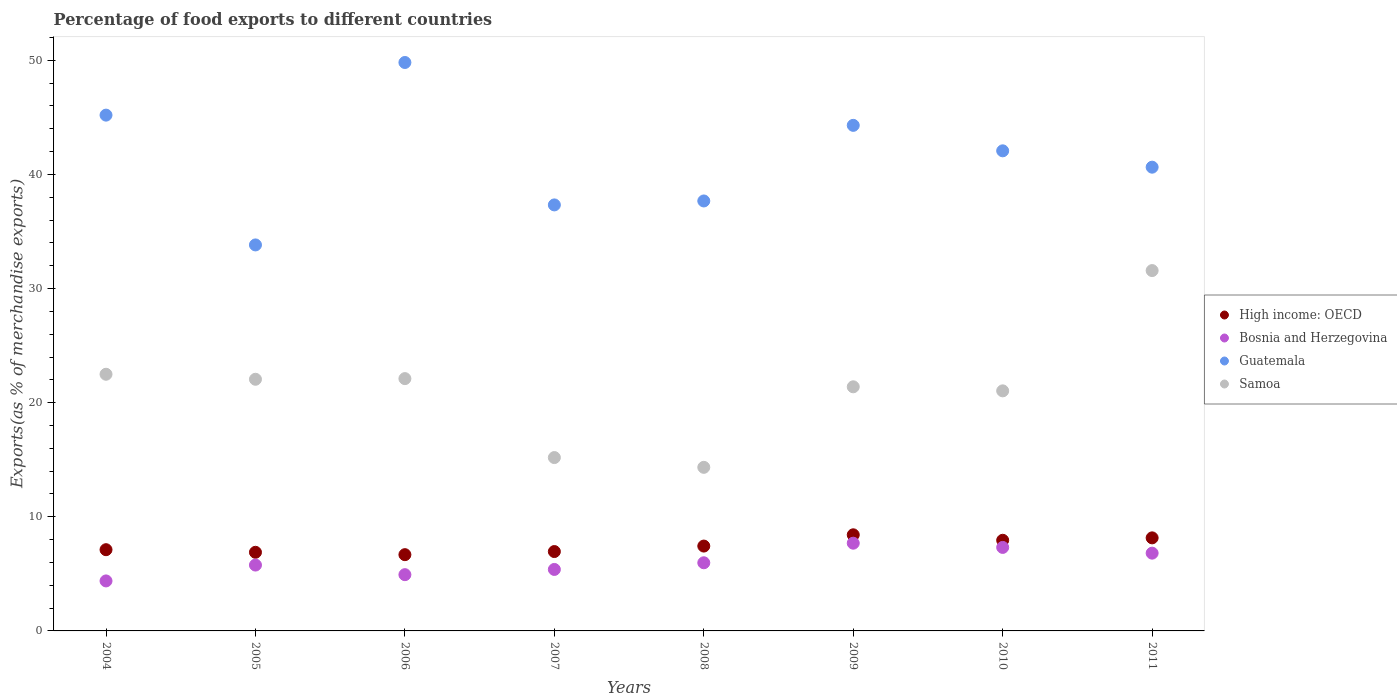How many different coloured dotlines are there?
Ensure brevity in your answer.  4. Is the number of dotlines equal to the number of legend labels?
Your answer should be very brief. Yes. What is the percentage of exports to different countries in Guatemala in 2008?
Ensure brevity in your answer.  37.67. Across all years, what is the maximum percentage of exports to different countries in High income: OECD?
Your answer should be compact. 8.42. Across all years, what is the minimum percentage of exports to different countries in Samoa?
Give a very brief answer. 14.33. What is the total percentage of exports to different countries in Samoa in the graph?
Provide a short and direct response. 170.17. What is the difference between the percentage of exports to different countries in Samoa in 2005 and that in 2010?
Offer a very short reply. 1.02. What is the difference between the percentage of exports to different countries in Samoa in 2006 and the percentage of exports to different countries in High income: OECD in 2008?
Provide a succinct answer. 14.67. What is the average percentage of exports to different countries in Samoa per year?
Give a very brief answer. 21.27. In the year 2006, what is the difference between the percentage of exports to different countries in Samoa and percentage of exports to different countries in Bosnia and Herzegovina?
Give a very brief answer. 17.18. What is the ratio of the percentage of exports to different countries in Bosnia and Herzegovina in 2007 to that in 2011?
Offer a very short reply. 0.79. Is the difference between the percentage of exports to different countries in Samoa in 2009 and 2010 greater than the difference between the percentage of exports to different countries in Bosnia and Herzegovina in 2009 and 2010?
Offer a very short reply. No. What is the difference between the highest and the second highest percentage of exports to different countries in Bosnia and Herzegovina?
Provide a short and direct response. 0.37. What is the difference between the highest and the lowest percentage of exports to different countries in High income: OECD?
Your response must be concise. 1.74. In how many years, is the percentage of exports to different countries in Guatemala greater than the average percentage of exports to different countries in Guatemala taken over all years?
Provide a short and direct response. 4. Is the sum of the percentage of exports to different countries in Guatemala in 2005 and 2011 greater than the maximum percentage of exports to different countries in Bosnia and Herzegovina across all years?
Your answer should be compact. Yes. Is it the case that in every year, the sum of the percentage of exports to different countries in High income: OECD and percentage of exports to different countries in Samoa  is greater than the sum of percentage of exports to different countries in Bosnia and Herzegovina and percentage of exports to different countries in Guatemala?
Offer a terse response. Yes. Is it the case that in every year, the sum of the percentage of exports to different countries in Samoa and percentage of exports to different countries in Guatemala  is greater than the percentage of exports to different countries in High income: OECD?
Offer a terse response. Yes. How many years are there in the graph?
Provide a short and direct response. 8. What is the difference between two consecutive major ticks on the Y-axis?
Give a very brief answer. 10. Does the graph contain grids?
Provide a short and direct response. No. How many legend labels are there?
Offer a terse response. 4. What is the title of the graph?
Your response must be concise. Percentage of food exports to different countries. Does "Belgium" appear as one of the legend labels in the graph?
Offer a very short reply. No. What is the label or title of the X-axis?
Provide a short and direct response. Years. What is the label or title of the Y-axis?
Ensure brevity in your answer.  Exports(as % of merchandise exports). What is the Exports(as % of merchandise exports) of High income: OECD in 2004?
Make the answer very short. 7.12. What is the Exports(as % of merchandise exports) in Bosnia and Herzegovina in 2004?
Give a very brief answer. 4.38. What is the Exports(as % of merchandise exports) in Guatemala in 2004?
Your answer should be very brief. 45.19. What is the Exports(as % of merchandise exports) in Samoa in 2004?
Make the answer very short. 22.49. What is the Exports(as % of merchandise exports) in High income: OECD in 2005?
Ensure brevity in your answer.  6.89. What is the Exports(as % of merchandise exports) in Bosnia and Herzegovina in 2005?
Provide a short and direct response. 5.77. What is the Exports(as % of merchandise exports) in Guatemala in 2005?
Your response must be concise. 33.82. What is the Exports(as % of merchandise exports) of Samoa in 2005?
Provide a short and direct response. 22.05. What is the Exports(as % of merchandise exports) in High income: OECD in 2006?
Your response must be concise. 6.68. What is the Exports(as % of merchandise exports) in Bosnia and Herzegovina in 2006?
Keep it short and to the point. 4.93. What is the Exports(as % of merchandise exports) in Guatemala in 2006?
Your answer should be very brief. 49.81. What is the Exports(as % of merchandise exports) of Samoa in 2006?
Offer a terse response. 22.11. What is the Exports(as % of merchandise exports) of High income: OECD in 2007?
Offer a very short reply. 6.95. What is the Exports(as % of merchandise exports) of Bosnia and Herzegovina in 2007?
Provide a short and direct response. 5.39. What is the Exports(as % of merchandise exports) in Guatemala in 2007?
Your answer should be very brief. 37.33. What is the Exports(as % of merchandise exports) in Samoa in 2007?
Make the answer very short. 15.19. What is the Exports(as % of merchandise exports) in High income: OECD in 2008?
Keep it short and to the point. 7.43. What is the Exports(as % of merchandise exports) of Bosnia and Herzegovina in 2008?
Your response must be concise. 5.97. What is the Exports(as % of merchandise exports) of Guatemala in 2008?
Your answer should be very brief. 37.67. What is the Exports(as % of merchandise exports) in Samoa in 2008?
Offer a very short reply. 14.33. What is the Exports(as % of merchandise exports) of High income: OECD in 2009?
Offer a very short reply. 8.42. What is the Exports(as % of merchandise exports) in Bosnia and Herzegovina in 2009?
Give a very brief answer. 7.69. What is the Exports(as % of merchandise exports) of Guatemala in 2009?
Your answer should be very brief. 44.3. What is the Exports(as % of merchandise exports) in Samoa in 2009?
Your response must be concise. 21.39. What is the Exports(as % of merchandise exports) of High income: OECD in 2010?
Offer a very short reply. 7.94. What is the Exports(as % of merchandise exports) of Bosnia and Herzegovina in 2010?
Your answer should be very brief. 7.32. What is the Exports(as % of merchandise exports) in Guatemala in 2010?
Offer a terse response. 42.07. What is the Exports(as % of merchandise exports) in Samoa in 2010?
Provide a short and direct response. 21.03. What is the Exports(as % of merchandise exports) of High income: OECD in 2011?
Your answer should be compact. 8.15. What is the Exports(as % of merchandise exports) in Bosnia and Herzegovina in 2011?
Your answer should be very brief. 6.81. What is the Exports(as % of merchandise exports) of Guatemala in 2011?
Provide a succinct answer. 40.63. What is the Exports(as % of merchandise exports) in Samoa in 2011?
Provide a succinct answer. 31.57. Across all years, what is the maximum Exports(as % of merchandise exports) in High income: OECD?
Ensure brevity in your answer.  8.42. Across all years, what is the maximum Exports(as % of merchandise exports) in Bosnia and Herzegovina?
Provide a succinct answer. 7.69. Across all years, what is the maximum Exports(as % of merchandise exports) of Guatemala?
Your answer should be compact. 49.81. Across all years, what is the maximum Exports(as % of merchandise exports) of Samoa?
Your response must be concise. 31.57. Across all years, what is the minimum Exports(as % of merchandise exports) in High income: OECD?
Provide a short and direct response. 6.68. Across all years, what is the minimum Exports(as % of merchandise exports) of Bosnia and Herzegovina?
Ensure brevity in your answer.  4.38. Across all years, what is the minimum Exports(as % of merchandise exports) in Guatemala?
Provide a short and direct response. 33.82. Across all years, what is the minimum Exports(as % of merchandise exports) of Samoa?
Provide a short and direct response. 14.33. What is the total Exports(as % of merchandise exports) in High income: OECD in the graph?
Ensure brevity in your answer.  59.6. What is the total Exports(as % of merchandise exports) of Bosnia and Herzegovina in the graph?
Give a very brief answer. 48.26. What is the total Exports(as % of merchandise exports) in Guatemala in the graph?
Make the answer very short. 330.83. What is the total Exports(as % of merchandise exports) in Samoa in the graph?
Provide a succinct answer. 170.17. What is the difference between the Exports(as % of merchandise exports) in High income: OECD in 2004 and that in 2005?
Your response must be concise. 0.23. What is the difference between the Exports(as % of merchandise exports) of Bosnia and Herzegovina in 2004 and that in 2005?
Give a very brief answer. -1.39. What is the difference between the Exports(as % of merchandise exports) of Guatemala in 2004 and that in 2005?
Ensure brevity in your answer.  11.37. What is the difference between the Exports(as % of merchandise exports) in Samoa in 2004 and that in 2005?
Your response must be concise. 0.44. What is the difference between the Exports(as % of merchandise exports) of High income: OECD in 2004 and that in 2006?
Keep it short and to the point. 0.44. What is the difference between the Exports(as % of merchandise exports) of Bosnia and Herzegovina in 2004 and that in 2006?
Offer a terse response. -0.55. What is the difference between the Exports(as % of merchandise exports) in Guatemala in 2004 and that in 2006?
Ensure brevity in your answer.  -4.61. What is the difference between the Exports(as % of merchandise exports) in Samoa in 2004 and that in 2006?
Your answer should be compact. 0.38. What is the difference between the Exports(as % of merchandise exports) in High income: OECD in 2004 and that in 2007?
Keep it short and to the point. 0.16. What is the difference between the Exports(as % of merchandise exports) of Bosnia and Herzegovina in 2004 and that in 2007?
Keep it short and to the point. -1.01. What is the difference between the Exports(as % of merchandise exports) of Guatemala in 2004 and that in 2007?
Keep it short and to the point. 7.87. What is the difference between the Exports(as % of merchandise exports) of Samoa in 2004 and that in 2007?
Provide a succinct answer. 7.3. What is the difference between the Exports(as % of merchandise exports) of High income: OECD in 2004 and that in 2008?
Offer a terse response. -0.32. What is the difference between the Exports(as % of merchandise exports) of Bosnia and Herzegovina in 2004 and that in 2008?
Provide a short and direct response. -1.59. What is the difference between the Exports(as % of merchandise exports) in Guatemala in 2004 and that in 2008?
Offer a very short reply. 7.52. What is the difference between the Exports(as % of merchandise exports) of Samoa in 2004 and that in 2008?
Offer a very short reply. 8.16. What is the difference between the Exports(as % of merchandise exports) of High income: OECD in 2004 and that in 2009?
Ensure brevity in your answer.  -1.3. What is the difference between the Exports(as % of merchandise exports) of Bosnia and Herzegovina in 2004 and that in 2009?
Offer a very short reply. -3.31. What is the difference between the Exports(as % of merchandise exports) in Guatemala in 2004 and that in 2009?
Your response must be concise. 0.9. What is the difference between the Exports(as % of merchandise exports) of Samoa in 2004 and that in 2009?
Your response must be concise. 1.1. What is the difference between the Exports(as % of merchandise exports) of High income: OECD in 2004 and that in 2010?
Give a very brief answer. -0.82. What is the difference between the Exports(as % of merchandise exports) in Bosnia and Herzegovina in 2004 and that in 2010?
Ensure brevity in your answer.  -2.94. What is the difference between the Exports(as % of merchandise exports) in Guatemala in 2004 and that in 2010?
Keep it short and to the point. 3.13. What is the difference between the Exports(as % of merchandise exports) in Samoa in 2004 and that in 2010?
Offer a terse response. 1.45. What is the difference between the Exports(as % of merchandise exports) in High income: OECD in 2004 and that in 2011?
Provide a succinct answer. -1.04. What is the difference between the Exports(as % of merchandise exports) of Bosnia and Herzegovina in 2004 and that in 2011?
Keep it short and to the point. -2.43. What is the difference between the Exports(as % of merchandise exports) in Guatemala in 2004 and that in 2011?
Provide a short and direct response. 4.56. What is the difference between the Exports(as % of merchandise exports) in Samoa in 2004 and that in 2011?
Give a very brief answer. -9.08. What is the difference between the Exports(as % of merchandise exports) in High income: OECD in 2005 and that in 2006?
Provide a succinct answer. 0.21. What is the difference between the Exports(as % of merchandise exports) of Bosnia and Herzegovina in 2005 and that in 2006?
Your answer should be very brief. 0.84. What is the difference between the Exports(as % of merchandise exports) of Guatemala in 2005 and that in 2006?
Your response must be concise. -15.99. What is the difference between the Exports(as % of merchandise exports) of Samoa in 2005 and that in 2006?
Offer a very short reply. -0.06. What is the difference between the Exports(as % of merchandise exports) in High income: OECD in 2005 and that in 2007?
Ensure brevity in your answer.  -0.06. What is the difference between the Exports(as % of merchandise exports) in Bosnia and Herzegovina in 2005 and that in 2007?
Ensure brevity in your answer.  0.38. What is the difference between the Exports(as % of merchandise exports) in Guatemala in 2005 and that in 2007?
Give a very brief answer. -3.51. What is the difference between the Exports(as % of merchandise exports) in Samoa in 2005 and that in 2007?
Make the answer very short. 6.86. What is the difference between the Exports(as % of merchandise exports) of High income: OECD in 2005 and that in 2008?
Make the answer very short. -0.55. What is the difference between the Exports(as % of merchandise exports) in Bosnia and Herzegovina in 2005 and that in 2008?
Offer a very short reply. -0.2. What is the difference between the Exports(as % of merchandise exports) of Guatemala in 2005 and that in 2008?
Make the answer very short. -3.85. What is the difference between the Exports(as % of merchandise exports) in Samoa in 2005 and that in 2008?
Your answer should be very brief. 7.72. What is the difference between the Exports(as % of merchandise exports) in High income: OECD in 2005 and that in 2009?
Give a very brief answer. -1.53. What is the difference between the Exports(as % of merchandise exports) of Bosnia and Herzegovina in 2005 and that in 2009?
Your answer should be very brief. -1.92. What is the difference between the Exports(as % of merchandise exports) of Guatemala in 2005 and that in 2009?
Provide a short and direct response. -10.48. What is the difference between the Exports(as % of merchandise exports) in Samoa in 2005 and that in 2009?
Provide a succinct answer. 0.66. What is the difference between the Exports(as % of merchandise exports) of High income: OECD in 2005 and that in 2010?
Offer a terse response. -1.05. What is the difference between the Exports(as % of merchandise exports) in Bosnia and Herzegovina in 2005 and that in 2010?
Give a very brief answer. -1.55. What is the difference between the Exports(as % of merchandise exports) in Guatemala in 2005 and that in 2010?
Give a very brief answer. -8.25. What is the difference between the Exports(as % of merchandise exports) of Samoa in 2005 and that in 2010?
Your answer should be compact. 1.02. What is the difference between the Exports(as % of merchandise exports) in High income: OECD in 2005 and that in 2011?
Make the answer very short. -1.26. What is the difference between the Exports(as % of merchandise exports) of Bosnia and Herzegovina in 2005 and that in 2011?
Make the answer very short. -1.04. What is the difference between the Exports(as % of merchandise exports) of Guatemala in 2005 and that in 2011?
Provide a succinct answer. -6.81. What is the difference between the Exports(as % of merchandise exports) in Samoa in 2005 and that in 2011?
Your response must be concise. -9.52. What is the difference between the Exports(as % of merchandise exports) in High income: OECD in 2006 and that in 2007?
Offer a terse response. -0.27. What is the difference between the Exports(as % of merchandise exports) of Bosnia and Herzegovina in 2006 and that in 2007?
Your answer should be compact. -0.46. What is the difference between the Exports(as % of merchandise exports) in Guatemala in 2006 and that in 2007?
Your answer should be compact. 12.48. What is the difference between the Exports(as % of merchandise exports) in Samoa in 2006 and that in 2007?
Keep it short and to the point. 6.92. What is the difference between the Exports(as % of merchandise exports) in High income: OECD in 2006 and that in 2008?
Offer a terse response. -0.75. What is the difference between the Exports(as % of merchandise exports) in Bosnia and Herzegovina in 2006 and that in 2008?
Your answer should be compact. -1.04. What is the difference between the Exports(as % of merchandise exports) of Guatemala in 2006 and that in 2008?
Make the answer very short. 12.13. What is the difference between the Exports(as % of merchandise exports) in Samoa in 2006 and that in 2008?
Make the answer very short. 7.77. What is the difference between the Exports(as % of merchandise exports) in High income: OECD in 2006 and that in 2009?
Your answer should be very brief. -1.74. What is the difference between the Exports(as % of merchandise exports) of Bosnia and Herzegovina in 2006 and that in 2009?
Keep it short and to the point. -2.76. What is the difference between the Exports(as % of merchandise exports) in Guatemala in 2006 and that in 2009?
Give a very brief answer. 5.51. What is the difference between the Exports(as % of merchandise exports) of Samoa in 2006 and that in 2009?
Your answer should be compact. 0.72. What is the difference between the Exports(as % of merchandise exports) of High income: OECD in 2006 and that in 2010?
Provide a succinct answer. -1.26. What is the difference between the Exports(as % of merchandise exports) of Bosnia and Herzegovina in 2006 and that in 2010?
Give a very brief answer. -2.39. What is the difference between the Exports(as % of merchandise exports) of Guatemala in 2006 and that in 2010?
Your answer should be very brief. 7.74. What is the difference between the Exports(as % of merchandise exports) of Samoa in 2006 and that in 2010?
Your answer should be very brief. 1.07. What is the difference between the Exports(as % of merchandise exports) of High income: OECD in 2006 and that in 2011?
Provide a succinct answer. -1.47. What is the difference between the Exports(as % of merchandise exports) in Bosnia and Herzegovina in 2006 and that in 2011?
Provide a succinct answer. -1.88. What is the difference between the Exports(as % of merchandise exports) of Guatemala in 2006 and that in 2011?
Give a very brief answer. 9.17. What is the difference between the Exports(as % of merchandise exports) of Samoa in 2006 and that in 2011?
Provide a short and direct response. -9.47. What is the difference between the Exports(as % of merchandise exports) of High income: OECD in 2007 and that in 2008?
Provide a succinct answer. -0.48. What is the difference between the Exports(as % of merchandise exports) in Bosnia and Herzegovina in 2007 and that in 2008?
Ensure brevity in your answer.  -0.58. What is the difference between the Exports(as % of merchandise exports) of Guatemala in 2007 and that in 2008?
Provide a succinct answer. -0.35. What is the difference between the Exports(as % of merchandise exports) in Samoa in 2007 and that in 2008?
Make the answer very short. 0.86. What is the difference between the Exports(as % of merchandise exports) of High income: OECD in 2007 and that in 2009?
Make the answer very short. -1.47. What is the difference between the Exports(as % of merchandise exports) of Bosnia and Herzegovina in 2007 and that in 2009?
Keep it short and to the point. -2.3. What is the difference between the Exports(as % of merchandise exports) of Guatemala in 2007 and that in 2009?
Your answer should be very brief. -6.97. What is the difference between the Exports(as % of merchandise exports) in Samoa in 2007 and that in 2009?
Keep it short and to the point. -6.2. What is the difference between the Exports(as % of merchandise exports) in High income: OECD in 2007 and that in 2010?
Your answer should be very brief. -0.99. What is the difference between the Exports(as % of merchandise exports) of Bosnia and Herzegovina in 2007 and that in 2010?
Provide a short and direct response. -1.93. What is the difference between the Exports(as % of merchandise exports) of Guatemala in 2007 and that in 2010?
Keep it short and to the point. -4.74. What is the difference between the Exports(as % of merchandise exports) in Samoa in 2007 and that in 2010?
Provide a short and direct response. -5.85. What is the difference between the Exports(as % of merchandise exports) in High income: OECD in 2007 and that in 2011?
Provide a succinct answer. -1.2. What is the difference between the Exports(as % of merchandise exports) of Bosnia and Herzegovina in 2007 and that in 2011?
Provide a succinct answer. -1.43. What is the difference between the Exports(as % of merchandise exports) in Guatemala in 2007 and that in 2011?
Give a very brief answer. -3.31. What is the difference between the Exports(as % of merchandise exports) in Samoa in 2007 and that in 2011?
Provide a succinct answer. -16.38. What is the difference between the Exports(as % of merchandise exports) in High income: OECD in 2008 and that in 2009?
Provide a succinct answer. -0.99. What is the difference between the Exports(as % of merchandise exports) in Bosnia and Herzegovina in 2008 and that in 2009?
Provide a short and direct response. -1.72. What is the difference between the Exports(as % of merchandise exports) in Guatemala in 2008 and that in 2009?
Provide a succinct answer. -6.63. What is the difference between the Exports(as % of merchandise exports) of Samoa in 2008 and that in 2009?
Your response must be concise. -7.06. What is the difference between the Exports(as % of merchandise exports) in High income: OECD in 2008 and that in 2010?
Give a very brief answer. -0.51. What is the difference between the Exports(as % of merchandise exports) in Bosnia and Herzegovina in 2008 and that in 2010?
Make the answer very short. -1.35. What is the difference between the Exports(as % of merchandise exports) of Guatemala in 2008 and that in 2010?
Your answer should be compact. -4.39. What is the difference between the Exports(as % of merchandise exports) of Samoa in 2008 and that in 2010?
Offer a very short reply. -6.7. What is the difference between the Exports(as % of merchandise exports) of High income: OECD in 2008 and that in 2011?
Offer a terse response. -0.72. What is the difference between the Exports(as % of merchandise exports) in Bosnia and Herzegovina in 2008 and that in 2011?
Keep it short and to the point. -0.84. What is the difference between the Exports(as % of merchandise exports) of Guatemala in 2008 and that in 2011?
Give a very brief answer. -2.96. What is the difference between the Exports(as % of merchandise exports) of Samoa in 2008 and that in 2011?
Your response must be concise. -17.24. What is the difference between the Exports(as % of merchandise exports) in High income: OECD in 2009 and that in 2010?
Your answer should be very brief. 0.48. What is the difference between the Exports(as % of merchandise exports) in Bosnia and Herzegovina in 2009 and that in 2010?
Offer a very short reply. 0.37. What is the difference between the Exports(as % of merchandise exports) of Guatemala in 2009 and that in 2010?
Your answer should be very brief. 2.23. What is the difference between the Exports(as % of merchandise exports) in Samoa in 2009 and that in 2010?
Give a very brief answer. 0.36. What is the difference between the Exports(as % of merchandise exports) in High income: OECD in 2009 and that in 2011?
Your answer should be compact. 0.27. What is the difference between the Exports(as % of merchandise exports) in Bosnia and Herzegovina in 2009 and that in 2011?
Give a very brief answer. 0.87. What is the difference between the Exports(as % of merchandise exports) in Guatemala in 2009 and that in 2011?
Your answer should be very brief. 3.66. What is the difference between the Exports(as % of merchandise exports) in Samoa in 2009 and that in 2011?
Keep it short and to the point. -10.18. What is the difference between the Exports(as % of merchandise exports) of High income: OECD in 2010 and that in 2011?
Your answer should be very brief. -0.21. What is the difference between the Exports(as % of merchandise exports) in Bosnia and Herzegovina in 2010 and that in 2011?
Offer a terse response. 0.5. What is the difference between the Exports(as % of merchandise exports) in Guatemala in 2010 and that in 2011?
Offer a terse response. 1.43. What is the difference between the Exports(as % of merchandise exports) in Samoa in 2010 and that in 2011?
Ensure brevity in your answer.  -10.54. What is the difference between the Exports(as % of merchandise exports) in High income: OECD in 2004 and the Exports(as % of merchandise exports) in Bosnia and Herzegovina in 2005?
Provide a short and direct response. 1.35. What is the difference between the Exports(as % of merchandise exports) in High income: OECD in 2004 and the Exports(as % of merchandise exports) in Guatemala in 2005?
Provide a succinct answer. -26.7. What is the difference between the Exports(as % of merchandise exports) in High income: OECD in 2004 and the Exports(as % of merchandise exports) in Samoa in 2005?
Make the answer very short. -14.93. What is the difference between the Exports(as % of merchandise exports) in Bosnia and Herzegovina in 2004 and the Exports(as % of merchandise exports) in Guatemala in 2005?
Your answer should be very brief. -29.44. What is the difference between the Exports(as % of merchandise exports) of Bosnia and Herzegovina in 2004 and the Exports(as % of merchandise exports) of Samoa in 2005?
Ensure brevity in your answer.  -17.67. What is the difference between the Exports(as % of merchandise exports) of Guatemala in 2004 and the Exports(as % of merchandise exports) of Samoa in 2005?
Your answer should be very brief. 23.14. What is the difference between the Exports(as % of merchandise exports) of High income: OECD in 2004 and the Exports(as % of merchandise exports) of Bosnia and Herzegovina in 2006?
Make the answer very short. 2.19. What is the difference between the Exports(as % of merchandise exports) of High income: OECD in 2004 and the Exports(as % of merchandise exports) of Guatemala in 2006?
Keep it short and to the point. -42.69. What is the difference between the Exports(as % of merchandise exports) of High income: OECD in 2004 and the Exports(as % of merchandise exports) of Samoa in 2006?
Make the answer very short. -14.99. What is the difference between the Exports(as % of merchandise exports) of Bosnia and Herzegovina in 2004 and the Exports(as % of merchandise exports) of Guatemala in 2006?
Ensure brevity in your answer.  -45.43. What is the difference between the Exports(as % of merchandise exports) of Bosnia and Herzegovina in 2004 and the Exports(as % of merchandise exports) of Samoa in 2006?
Offer a very short reply. -17.73. What is the difference between the Exports(as % of merchandise exports) of Guatemala in 2004 and the Exports(as % of merchandise exports) of Samoa in 2006?
Your answer should be compact. 23.09. What is the difference between the Exports(as % of merchandise exports) of High income: OECD in 2004 and the Exports(as % of merchandise exports) of Bosnia and Herzegovina in 2007?
Give a very brief answer. 1.73. What is the difference between the Exports(as % of merchandise exports) of High income: OECD in 2004 and the Exports(as % of merchandise exports) of Guatemala in 2007?
Make the answer very short. -30.21. What is the difference between the Exports(as % of merchandise exports) of High income: OECD in 2004 and the Exports(as % of merchandise exports) of Samoa in 2007?
Offer a very short reply. -8.07. What is the difference between the Exports(as % of merchandise exports) of Bosnia and Herzegovina in 2004 and the Exports(as % of merchandise exports) of Guatemala in 2007?
Offer a very short reply. -32.95. What is the difference between the Exports(as % of merchandise exports) in Bosnia and Herzegovina in 2004 and the Exports(as % of merchandise exports) in Samoa in 2007?
Ensure brevity in your answer.  -10.81. What is the difference between the Exports(as % of merchandise exports) in Guatemala in 2004 and the Exports(as % of merchandise exports) in Samoa in 2007?
Offer a terse response. 30.01. What is the difference between the Exports(as % of merchandise exports) of High income: OECD in 2004 and the Exports(as % of merchandise exports) of Bosnia and Herzegovina in 2008?
Ensure brevity in your answer.  1.15. What is the difference between the Exports(as % of merchandise exports) of High income: OECD in 2004 and the Exports(as % of merchandise exports) of Guatemala in 2008?
Provide a succinct answer. -30.56. What is the difference between the Exports(as % of merchandise exports) of High income: OECD in 2004 and the Exports(as % of merchandise exports) of Samoa in 2008?
Your response must be concise. -7.22. What is the difference between the Exports(as % of merchandise exports) in Bosnia and Herzegovina in 2004 and the Exports(as % of merchandise exports) in Guatemala in 2008?
Your response must be concise. -33.29. What is the difference between the Exports(as % of merchandise exports) of Bosnia and Herzegovina in 2004 and the Exports(as % of merchandise exports) of Samoa in 2008?
Make the answer very short. -9.95. What is the difference between the Exports(as % of merchandise exports) of Guatemala in 2004 and the Exports(as % of merchandise exports) of Samoa in 2008?
Your response must be concise. 30.86. What is the difference between the Exports(as % of merchandise exports) in High income: OECD in 2004 and the Exports(as % of merchandise exports) in Bosnia and Herzegovina in 2009?
Make the answer very short. -0.57. What is the difference between the Exports(as % of merchandise exports) in High income: OECD in 2004 and the Exports(as % of merchandise exports) in Guatemala in 2009?
Your answer should be very brief. -37.18. What is the difference between the Exports(as % of merchandise exports) of High income: OECD in 2004 and the Exports(as % of merchandise exports) of Samoa in 2009?
Keep it short and to the point. -14.27. What is the difference between the Exports(as % of merchandise exports) in Bosnia and Herzegovina in 2004 and the Exports(as % of merchandise exports) in Guatemala in 2009?
Your answer should be compact. -39.92. What is the difference between the Exports(as % of merchandise exports) in Bosnia and Herzegovina in 2004 and the Exports(as % of merchandise exports) in Samoa in 2009?
Make the answer very short. -17.01. What is the difference between the Exports(as % of merchandise exports) in Guatemala in 2004 and the Exports(as % of merchandise exports) in Samoa in 2009?
Your response must be concise. 23.8. What is the difference between the Exports(as % of merchandise exports) of High income: OECD in 2004 and the Exports(as % of merchandise exports) of Bosnia and Herzegovina in 2010?
Provide a succinct answer. -0.2. What is the difference between the Exports(as % of merchandise exports) of High income: OECD in 2004 and the Exports(as % of merchandise exports) of Guatemala in 2010?
Your answer should be very brief. -34.95. What is the difference between the Exports(as % of merchandise exports) of High income: OECD in 2004 and the Exports(as % of merchandise exports) of Samoa in 2010?
Your answer should be compact. -13.92. What is the difference between the Exports(as % of merchandise exports) of Bosnia and Herzegovina in 2004 and the Exports(as % of merchandise exports) of Guatemala in 2010?
Provide a short and direct response. -37.69. What is the difference between the Exports(as % of merchandise exports) in Bosnia and Herzegovina in 2004 and the Exports(as % of merchandise exports) in Samoa in 2010?
Provide a succinct answer. -16.65. What is the difference between the Exports(as % of merchandise exports) of Guatemala in 2004 and the Exports(as % of merchandise exports) of Samoa in 2010?
Make the answer very short. 24.16. What is the difference between the Exports(as % of merchandise exports) in High income: OECD in 2004 and the Exports(as % of merchandise exports) in Bosnia and Herzegovina in 2011?
Make the answer very short. 0.3. What is the difference between the Exports(as % of merchandise exports) of High income: OECD in 2004 and the Exports(as % of merchandise exports) of Guatemala in 2011?
Provide a short and direct response. -33.52. What is the difference between the Exports(as % of merchandise exports) in High income: OECD in 2004 and the Exports(as % of merchandise exports) in Samoa in 2011?
Give a very brief answer. -24.46. What is the difference between the Exports(as % of merchandise exports) of Bosnia and Herzegovina in 2004 and the Exports(as % of merchandise exports) of Guatemala in 2011?
Provide a short and direct response. -36.25. What is the difference between the Exports(as % of merchandise exports) of Bosnia and Herzegovina in 2004 and the Exports(as % of merchandise exports) of Samoa in 2011?
Ensure brevity in your answer.  -27.19. What is the difference between the Exports(as % of merchandise exports) of Guatemala in 2004 and the Exports(as % of merchandise exports) of Samoa in 2011?
Offer a terse response. 13.62. What is the difference between the Exports(as % of merchandise exports) in High income: OECD in 2005 and the Exports(as % of merchandise exports) in Bosnia and Herzegovina in 2006?
Your response must be concise. 1.96. What is the difference between the Exports(as % of merchandise exports) in High income: OECD in 2005 and the Exports(as % of merchandise exports) in Guatemala in 2006?
Your answer should be very brief. -42.92. What is the difference between the Exports(as % of merchandise exports) in High income: OECD in 2005 and the Exports(as % of merchandise exports) in Samoa in 2006?
Your answer should be very brief. -15.22. What is the difference between the Exports(as % of merchandise exports) of Bosnia and Herzegovina in 2005 and the Exports(as % of merchandise exports) of Guatemala in 2006?
Your response must be concise. -44.04. What is the difference between the Exports(as % of merchandise exports) in Bosnia and Herzegovina in 2005 and the Exports(as % of merchandise exports) in Samoa in 2006?
Your answer should be very brief. -16.34. What is the difference between the Exports(as % of merchandise exports) of Guatemala in 2005 and the Exports(as % of merchandise exports) of Samoa in 2006?
Your answer should be compact. 11.71. What is the difference between the Exports(as % of merchandise exports) in High income: OECD in 2005 and the Exports(as % of merchandise exports) in Bosnia and Herzegovina in 2007?
Your response must be concise. 1.5. What is the difference between the Exports(as % of merchandise exports) in High income: OECD in 2005 and the Exports(as % of merchandise exports) in Guatemala in 2007?
Offer a very short reply. -30.44. What is the difference between the Exports(as % of merchandise exports) in High income: OECD in 2005 and the Exports(as % of merchandise exports) in Samoa in 2007?
Give a very brief answer. -8.3. What is the difference between the Exports(as % of merchandise exports) of Bosnia and Herzegovina in 2005 and the Exports(as % of merchandise exports) of Guatemala in 2007?
Provide a succinct answer. -31.56. What is the difference between the Exports(as % of merchandise exports) of Bosnia and Herzegovina in 2005 and the Exports(as % of merchandise exports) of Samoa in 2007?
Ensure brevity in your answer.  -9.42. What is the difference between the Exports(as % of merchandise exports) of Guatemala in 2005 and the Exports(as % of merchandise exports) of Samoa in 2007?
Make the answer very short. 18.63. What is the difference between the Exports(as % of merchandise exports) of High income: OECD in 2005 and the Exports(as % of merchandise exports) of Bosnia and Herzegovina in 2008?
Your answer should be very brief. 0.92. What is the difference between the Exports(as % of merchandise exports) in High income: OECD in 2005 and the Exports(as % of merchandise exports) in Guatemala in 2008?
Give a very brief answer. -30.78. What is the difference between the Exports(as % of merchandise exports) of High income: OECD in 2005 and the Exports(as % of merchandise exports) of Samoa in 2008?
Make the answer very short. -7.44. What is the difference between the Exports(as % of merchandise exports) in Bosnia and Herzegovina in 2005 and the Exports(as % of merchandise exports) in Guatemala in 2008?
Ensure brevity in your answer.  -31.9. What is the difference between the Exports(as % of merchandise exports) in Bosnia and Herzegovina in 2005 and the Exports(as % of merchandise exports) in Samoa in 2008?
Ensure brevity in your answer.  -8.56. What is the difference between the Exports(as % of merchandise exports) of Guatemala in 2005 and the Exports(as % of merchandise exports) of Samoa in 2008?
Keep it short and to the point. 19.49. What is the difference between the Exports(as % of merchandise exports) of High income: OECD in 2005 and the Exports(as % of merchandise exports) of Bosnia and Herzegovina in 2009?
Keep it short and to the point. -0.8. What is the difference between the Exports(as % of merchandise exports) in High income: OECD in 2005 and the Exports(as % of merchandise exports) in Guatemala in 2009?
Make the answer very short. -37.41. What is the difference between the Exports(as % of merchandise exports) of High income: OECD in 2005 and the Exports(as % of merchandise exports) of Samoa in 2009?
Keep it short and to the point. -14.5. What is the difference between the Exports(as % of merchandise exports) in Bosnia and Herzegovina in 2005 and the Exports(as % of merchandise exports) in Guatemala in 2009?
Provide a short and direct response. -38.53. What is the difference between the Exports(as % of merchandise exports) in Bosnia and Herzegovina in 2005 and the Exports(as % of merchandise exports) in Samoa in 2009?
Provide a succinct answer. -15.62. What is the difference between the Exports(as % of merchandise exports) in Guatemala in 2005 and the Exports(as % of merchandise exports) in Samoa in 2009?
Provide a succinct answer. 12.43. What is the difference between the Exports(as % of merchandise exports) of High income: OECD in 2005 and the Exports(as % of merchandise exports) of Bosnia and Herzegovina in 2010?
Keep it short and to the point. -0.43. What is the difference between the Exports(as % of merchandise exports) in High income: OECD in 2005 and the Exports(as % of merchandise exports) in Guatemala in 2010?
Keep it short and to the point. -35.18. What is the difference between the Exports(as % of merchandise exports) in High income: OECD in 2005 and the Exports(as % of merchandise exports) in Samoa in 2010?
Provide a short and direct response. -14.15. What is the difference between the Exports(as % of merchandise exports) of Bosnia and Herzegovina in 2005 and the Exports(as % of merchandise exports) of Guatemala in 2010?
Offer a very short reply. -36.3. What is the difference between the Exports(as % of merchandise exports) of Bosnia and Herzegovina in 2005 and the Exports(as % of merchandise exports) of Samoa in 2010?
Give a very brief answer. -15.26. What is the difference between the Exports(as % of merchandise exports) in Guatemala in 2005 and the Exports(as % of merchandise exports) in Samoa in 2010?
Offer a terse response. 12.79. What is the difference between the Exports(as % of merchandise exports) in High income: OECD in 2005 and the Exports(as % of merchandise exports) in Bosnia and Herzegovina in 2011?
Offer a terse response. 0.08. What is the difference between the Exports(as % of merchandise exports) of High income: OECD in 2005 and the Exports(as % of merchandise exports) of Guatemala in 2011?
Your answer should be compact. -33.74. What is the difference between the Exports(as % of merchandise exports) of High income: OECD in 2005 and the Exports(as % of merchandise exports) of Samoa in 2011?
Provide a succinct answer. -24.68. What is the difference between the Exports(as % of merchandise exports) in Bosnia and Herzegovina in 2005 and the Exports(as % of merchandise exports) in Guatemala in 2011?
Offer a very short reply. -34.86. What is the difference between the Exports(as % of merchandise exports) in Bosnia and Herzegovina in 2005 and the Exports(as % of merchandise exports) in Samoa in 2011?
Ensure brevity in your answer.  -25.8. What is the difference between the Exports(as % of merchandise exports) of Guatemala in 2005 and the Exports(as % of merchandise exports) of Samoa in 2011?
Provide a short and direct response. 2.25. What is the difference between the Exports(as % of merchandise exports) of High income: OECD in 2006 and the Exports(as % of merchandise exports) of Bosnia and Herzegovina in 2007?
Make the answer very short. 1.29. What is the difference between the Exports(as % of merchandise exports) in High income: OECD in 2006 and the Exports(as % of merchandise exports) in Guatemala in 2007?
Provide a succinct answer. -30.65. What is the difference between the Exports(as % of merchandise exports) of High income: OECD in 2006 and the Exports(as % of merchandise exports) of Samoa in 2007?
Your answer should be compact. -8.51. What is the difference between the Exports(as % of merchandise exports) of Bosnia and Herzegovina in 2006 and the Exports(as % of merchandise exports) of Guatemala in 2007?
Provide a short and direct response. -32.4. What is the difference between the Exports(as % of merchandise exports) of Bosnia and Herzegovina in 2006 and the Exports(as % of merchandise exports) of Samoa in 2007?
Your response must be concise. -10.26. What is the difference between the Exports(as % of merchandise exports) in Guatemala in 2006 and the Exports(as % of merchandise exports) in Samoa in 2007?
Offer a very short reply. 34.62. What is the difference between the Exports(as % of merchandise exports) in High income: OECD in 2006 and the Exports(as % of merchandise exports) in Bosnia and Herzegovina in 2008?
Provide a short and direct response. 0.71. What is the difference between the Exports(as % of merchandise exports) of High income: OECD in 2006 and the Exports(as % of merchandise exports) of Guatemala in 2008?
Your answer should be very brief. -30.99. What is the difference between the Exports(as % of merchandise exports) of High income: OECD in 2006 and the Exports(as % of merchandise exports) of Samoa in 2008?
Provide a succinct answer. -7.65. What is the difference between the Exports(as % of merchandise exports) in Bosnia and Herzegovina in 2006 and the Exports(as % of merchandise exports) in Guatemala in 2008?
Ensure brevity in your answer.  -32.74. What is the difference between the Exports(as % of merchandise exports) of Bosnia and Herzegovina in 2006 and the Exports(as % of merchandise exports) of Samoa in 2008?
Provide a short and direct response. -9.4. What is the difference between the Exports(as % of merchandise exports) in Guatemala in 2006 and the Exports(as % of merchandise exports) in Samoa in 2008?
Give a very brief answer. 35.47. What is the difference between the Exports(as % of merchandise exports) of High income: OECD in 2006 and the Exports(as % of merchandise exports) of Bosnia and Herzegovina in 2009?
Keep it short and to the point. -1.01. What is the difference between the Exports(as % of merchandise exports) of High income: OECD in 2006 and the Exports(as % of merchandise exports) of Guatemala in 2009?
Offer a very short reply. -37.62. What is the difference between the Exports(as % of merchandise exports) in High income: OECD in 2006 and the Exports(as % of merchandise exports) in Samoa in 2009?
Provide a succinct answer. -14.71. What is the difference between the Exports(as % of merchandise exports) in Bosnia and Herzegovina in 2006 and the Exports(as % of merchandise exports) in Guatemala in 2009?
Your response must be concise. -39.37. What is the difference between the Exports(as % of merchandise exports) in Bosnia and Herzegovina in 2006 and the Exports(as % of merchandise exports) in Samoa in 2009?
Offer a very short reply. -16.46. What is the difference between the Exports(as % of merchandise exports) in Guatemala in 2006 and the Exports(as % of merchandise exports) in Samoa in 2009?
Ensure brevity in your answer.  28.42. What is the difference between the Exports(as % of merchandise exports) of High income: OECD in 2006 and the Exports(as % of merchandise exports) of Bosnia and Herzegovina in 2010?
Provide a short and direct response. -0.63. What is the difference between the Exports(as % of merchandise exports) of High income: OECD in 2006 and the Exports(as % of merchandise exports) of Guatemala in 2010?
Ensure brevity in your answer.  -35.39. What is the difference between the Exports(as % of merchandise exports) of High income: OECD in 2006 and the Exports(as % of merchandise exports) of Samoa in 2010?
Ensure brevity in your answer.  -14.35. What is the difference between the Exports(as % of merchandise exports) of Bosnia and Herzegovina in 2006 and the Exports(as % of merchandise exports) of Guatemala in 2010?
Your answer should be compact. -37.14. What is the difference between the Exports(as % of merchandise exports) of Bosnia and Herzegovina in 2006 and the Exports(as % of merchandise exports) of Samoa in 2010?
Make the answer very short. -16.11. What is the difference between the Exports(as % of merchandise exports) in Guatemala in 2006 and the Exports(as % of merchandise exports) in Samoa in 2010?
Your answer should be compact. 28.77. What is the difference between the Exports(as % of merchandise exports) of High income: OECD in 2006 and the Exports(as % of merchandise exports) of Bosnia and Herzegovina in 2011?
Ensure brevity in your answer.  -0.13. What is the difference between the Exports(as % of merchandise exports) of High income: OECD in 2006 and the Exports(as % of merchandise exports) of Guatemala in 2011?
Ensure brevity in your answer.  -33.95. What is the difference between the Exports(as % of merchandise exports) of High income: OECD in 2006 and the Exports(as % of merchandise exports) of Samoa in 2011?
Ensure brevity in your answer.  -24.89. What is the difference between the Exports(as % of merchandise exports) of Bosnia and Herzegovina in 2006 and the Exports(as % of merchandise exports) of Guatemala in 2011?
Give a very brief answer. -35.7. What is the difference between the Exports(as % of merchandise exports) of Bosnia and Herzegovina in 2006 and the Exports(as % of merchandise exports) of Samoa in 2011?
Give a very brief answer. -26.64. What is the difference between the Exports(as % of merchandise exports) of Guatemala in 2006 and the Exports(as % of merchandise exports) of Samoa in 2011?
Provide a succinct answer. 18.23. What is the difference between the Exports(as % of merchandise exports) in High income: OECD in 2007 and the Exports(as % of merchandise exports) in Bosnia and Herzegovina in 2008?
Provide a succinct answer. 0.98. What is the difference between the Exports(as % of merchandise exports) of High income: OECD in 2007 and the Exports(as % of merchandise exports) of Guatemala in 2008?
Keep it short and to the point. -30.72. What is the difference between the Exports(as % of merchandise exports) in High income: OECD in 2007 and the Exports(as % of merchandise exports) in Samoa in 2008?
Your response must be concise. -7.38. What is the difference between the Exports(as % of merchandise exports) of Bosnia and Herzegovina in 2007 and the Exports(as % of merchandise exports) of Guatemala in 2008?
Your answer should be very brief. -32.29. What is the difference between the Exports(as % of merchandise exports) in Bosnia and Herzegovina in 2007 and the Exports(as % of merchandise exports) in Samoa in 2008?
Ensure brevity in your answer.  -8.95. What is the difference between the Exports(as % of merchandise exports) in Guatemala in 2007 and the Exports(as % of merchandise exports) in Samoa in 2008?
Your answer should be very brief. 22.99. What is the difference between the Exports(as % of merchandise exports) of High income: OECD in 2007 and the Exports(as % of merchandise exports) of Bosnia and Herzegovina in 2009?
Your answer should be very brief. -0.73. What is the difference between the Exports(as % of merchandise exports) in High income: OECD in 2007 and the Exports(as % of merchandise exports) in Guatemala in 2009?
Offer a very short reply. -37.34. What is the difference between the Exports(as % of merchandise exports) of High income: OECD in 2007 and the Exports(as % of merchandise exports) of Samoa in 2009?
Offer a terse response. -14.44. What is the difference between the Exports(as % of merchandise exports) of Bosnia and Herzegovina in 2007 and the Exports(as % of merchandise exports) of Guatemala in 2009?
Your answer should be very brief. -38.91. What is the difference between the Exports(as % of merchandise exports) in Bosnia and Herzegovina in 2007 and the Exports(as % of merchandise exports) in Samoa in 2009?
Provide a short and direct response. -16. What is the difference between the Exports(as % of merchandise exports) in Guatemala in 2007 and the Exports(as % of merchandise exports) in Samoa in 2009?
Make the answer very short. 15.94. What is the difference between the Exports(as % of merchandise exports) in High income: OECD in 2007 and the Exports(as % of merchandise exports) in Bosnia and Herzegovina in 2010?
Make the answer very short. -0.36. What is the difference between the Exports(as % of merchandise exports) in High income: OECD in 2007 and the Exports(as % of merchandise exports) in Guatemala in 2010?
Your response must be concise. -35.11. What is the difference between the Exports(as % of merchandise exports) of High income: OECD in 2007 and the Exports(as % of merchandise exports) of Samoa in 2010?
Provide a succinct answer. -14.08. What is the difference between the Exports(as % of merchandise exports) of Bosnia and Herzegovina in 2007 and the Exports(as % of merchandise exports) of Guatemala in 2010?
Offer a very short reply. -36.68. What is the difference between the Exports(as % of merchandise exports) in Bosnia and Herzegovina in 2007 and the Exports(as % of merchandise exports) in Samoa in 2010?
Offer a very short reply. -15.65. What is the difference between the Exports(as % of merchandise exports) in Guatemala in 2007 and the Exports(as % of merchandise exports) in Samoa in 2010?
Offer a very short reply. 16.29. What is the difference between the Exports(as % of merchandise exports) of High income: OECD in 2007 and the Exports(as % of merchandise exports) of Bosnia and Herzegovina in 2011?
Offer a terse response. 0.14. What is the difference between the Exports(as % of merchandise exports) of High income: OECD in 2007 and the Exports(as % of merchandise exports) of Guatemala in 2011?
Offer a terse response. -33.68. What is the difference between the Exports(as % of merchandise exports) in High income: OECD in 2007 and the Exports(as % of merchandise exports) in Samoa in 2011?
Offer a very short reply. -24.62. What is the difference between the Exports(as % of merchandise exports) of Bosnia and Herzegovina in 2007 and the Exports(as % of merchandise exports) of Guatemala in 2011?
Offer a terse response. -35.25. What is the difference between the Exports(as % of merchandise exports) of Bosnia and Herzegovina in 2007 and the Exports(as % of merchandise exports) of Samoa in 2011?
Provide a succinct answer. -26.19. What is the difference between the Exports(as % of merchandise exports) in Guatemala in 2007 and the Exports(as % of merchandise exports) in Samoa in 2011?
Offer a terse response. 5.75. What is the difference between the Exports(as % of merchandise exports) of High income: OECD in 2008 and the Exports(as % of merchandise exports) of Bosnia and Herzegovina in 2009?
Provide a succinct answer. -0.25. What is the difference between the Exports(as % of merchandise exports) in High income: OECD in 2008 and the Exports(as % of merchandise exports) in Guatemala in 2009?
Give a very brief answer. -36.86. What is the difference between the Exports(as % of merchandise exports) in High income: OECD in 2008 and the Exports(as % of merchandise exports) in Samoa in 2009?
Your response must be concise. -13.96. What is the difference between the Exports(as % of merchandise exports) of Bosnia and Herzegovina in 2008 and the Exports(as % of merchandise exports) of Guatemala in 2009?
Offer a very short reply. -38.33. What is the difference between the Exports(as % of merchandise exports) in Bosnia and Herzegovina in 2008 and the Exports(as % of merchandise exports) in Samoa in 2009?
Your answer should be very brief. -15.42. What is the difference between the Exports(as % of merchandise exports) of Guatemala in 2008 and the Exports(as % of merchandise exports) of Samoa in 2009?
Ensure brevity in your answer.  16.28. What is the difference between the Exports(as % of merchandise exports) in High income: OECD in 2008 and the Exports(as % of merchandise exports) in Bosnia and Herzegovina in 2010?
Keep it short and to the point. 0.12. What is the difference between the Exports(as % of merchandise exports) of High income: OECD in 2008 and the Exports(as % of merchandise exports) of Guatemala in 2010?
Your answer should be compact. -34.63. What is the difference between the Exports(as % of merchandise exports) in Bosnia and Herzegovina in 2008 and the Exports(as % of merchandise exports) in Guatemala in 2010?
Ensure brevity in your answer.  -36.1. What is the difference between the Exports(as % of merchandise exports) of Bosnia and Herzegovina in 2008 and the Exports(as % of merchandise exports) of Samoa in 2010?
Give a very brief answer. -15.06. What is the difference between the Exports(as % of merchandise exports) in Guatemala in 2008 and the Exports(as % of merchandise exports) in Samoa in 2010?
Give a very brief answer. 16.64. What is the difference between the Exports(as % of merchandise exports) of High income: OECD in 2008 and the Exports(as % of merchandise exports) of Bosnia and Herzegovina in 2011?
Provide a succinct answer. 0.62. What is the difference between the Exports(as % of merchandise exports) of High income: OECD in 2008 and the Exports(as % of merchandise exports) of Guatemala in 2011?
Your response must be concise. -33.2. What is the difference between the Exports(as % of merchandise exports) of High income: OECD in 2008 and the Exports(as % of merchandise exports) of Samoa in 2011?
Your response must be concise. -24.14. What is the difference between the Exports(as % of merchandise exports) of Bosnia and Herzegovina in 2008 and the Exports(as % of merchandise exports) of Guatemala in 2011?
Keep it short and to the point. -34.66. What is the difference between the Exports(as % of merchandise exports) in Bosnia and Herzegovina in 2008 and the Exports(as % of merchandise exports) in Samoa in 2011?
Your answer should be compact. -25.6. What is the difference between the Exports(as % of merchandise exports) in High income: OECD in 2009 and the Exports(as % of merchandise exports) in Bosnia and Herzegovina in 2010?
Make the answer very short. 1.1. What is the difference between the Exports(as % of merchandise exports) of High income: OECD in 2009 and the Exports(as % of merchandise exports) of Guatemala in 2010?
Make the answer very short. -33.65. What is the difference between the Exports(as % of merchandise exports) in High income: OECD in 2009 and the Exports(as % of merchandise exports) in Samoa in 2010?
Make the answer very short. -12.61. What is the difference between the Exports(as % of merchandise exports) in Bosnia and Herzegovina in 2009 and the Exports(as % of merchandise exports) in Guatemala in 2010?
Provide a short and direct response. -34.38. What is the difference between the Exports(as % of merchandise exports) in Bosnia and Herzegovina in 2009 and the Exports(as % of merchandise exports) in Samoa in 2010?
Offer a terse response. -13.35. What is the difference between the Exports(as % of merchandise exports) of Guatemala in 2009 and the Exports(as % of merchandise exports) of Samoa in 2010?
Provide a short and direct response. 23.26. What is the difference between the Exports(as % of merchandise exports) in High income: OECD in 2009 and the Exports(as % of merchandise exports) in Bosnia and Herzegovina in 2011?
Offer a terse response. 1.61. What is the difference between the Exports(as % of merchandise exports) of High income: OECD in 2009 and the Exports(as % of merchandise exports) of Guatemala in 2011?
Your response must be concise. -32.21. What is the difference between the Exports(as % of merchandise exports) in High income: OECD in 2009 and the Exports(as % of merchandise exports) in Samoa in 2011?
Keep it short and to the point. -23.15. What is the difference between the Exports(as % of merchandise exports) of Bosnia and Herzegovina in 2009 and the Exports(as % of merchandise exports) of Guatemala in 2011?
Offer a terse response. -32.95. What is the difference between the Exports(as % of merchandise exports) of Bosnia and Herzegovina in 2009 and the Exports(as % of merchandise exports) of Samoa in 2011?
Make the answer very short. -23.89. What is the difference between the Exports(as % of merchandise exports) of Guatemala in 2009 and the Exports(as % of merchandise exports) of Samoa in 2011?
Offer a very short reply. 12.73. What is the difference between the Exports(as % of merchandise exports) of High income: OECD in 2010 and the Exports(as % of merchandise exports) of Bosnia and Herzegovina in 2011?
Offer a terse response. 1.13. What is the difference between the Exports(as % of merchandise exports) of High income: OECD in 2010 and the Exports(as % of merchandise exports) of Guatemala in 2011?
Give a very brief answer. -32.69. What is the difference between the Exports(as % of merchandise exports) in High income: OECD in 2010 and the Exports(as % of merchandise exports) in Samoa in 2011?
Give a very brief answer. -23.63. What is the difference between the Exports(as % of merchandise exports) in Bosnia and Herzegovina in 2010 and the Exports(as % of merchandise exports) in Guatemala in 2011?
Provide a short and direct response. -33.32. What is the difference between the Exports(as % of merchandise exports) of Bosnia and Herzegovina in 2010 and the Exports(as % of merchandise exports) of Samoa in 2011?
Offer a terse response. -24.26. What is the difference between the Exports(as % of merchandise exports) in Guatemala in 2010 and the Exports(as % of merchandise exports) in Samoa in 2011?
Offer a very short reply. 10.49. What is the average Exports(as % of merchandise exports) of High income: OECD per year?
Ensure brevity in your answer.  7.45. What is the average Exports(as % of merchandise exports) of Bosnia and Herzegovina per year?
Provide a short and direct response. 6.03. What is the average Exports(as % of merchandise exports) of Guatemala per year?
Make the answer very short. 41.35. What is the average Exports(as % of merchandise exports) of Samoa per year?
Ensure brevity in your answer.  21.27. In the year 2004, what is the difference between the Exports(as % of merchandise exports) in High income: OECD and Exports(as % of merchandise exports) in Bosnia and Herzegovina?
Your answer should be compact. 2.74. In the year 2004, what is the difference between the Exports(as % of merchandise exports) of High income: OECD and Exports(as % of merchandise exports) of Guatemala?
Make the answer very short. -38.08. In the year 2004, what is the difference between the Exports(as % of merchandise exports) of High income: OECD and Exports(as % of merchandise exports) of Samoa?
Provide a short and direct response. -15.37. In the year 2004, what is the difference between the Exports(as % of merchandise exports) in Bosnia and Herzegovina and Exports(as % of merchandise exports) in Guatemala?
Keep it short and to the point. -40.81. In the year 2004, what is the difference between the Exports(as % of merchandise exports) of Bosnia and Herzegovina and Exports(as % of merchandise exports) of Samoa?
Provide a succinct answer. -18.11. In the year 2004, what is the difference between the Exports(as % of merchandise exports) of Guatemala and Exports(as % of merchandise exports) of Samoa?
Make the answer very short. 22.71. In the year 2005, what is the difference between the Exports(as % of merchandise exports) of High income: OECD and Exports(as % of merchandise exports) of Bosnia and Herzegovina?
Your answer should be very brief. 1.12. In the year 2005, what is the difference between the Exports(as % of merchandise exports) of High income: OECD and Exports(as % of merchandise exports) of Guatemala?
Your answer should be compact. -26.93. In the year 2005, what is the difference between the Exports(as % of merchandise exports) in High income: OECD and Exports(as % of merchandise exports) in Samoa?
Your answer should be compact. -15.16. In the year 2005, what is the difference between the Exports(as % of merchandise exports) of Bosnia and Herzegovina and Exports(as % of merchandise exports) of Guatemala?
Provide a short and direct response. -28.05. In the year 2005, what is the difference between the Exports(as % of merchandise exports) in Bosnia and Herzegovina and Exports(as % of merchandise exports) in Samoa?
Offer a very short reply. -16.28. In the year 2005, what is the difference between the Exports(as % of merchandise exports) in Guatemala and Exports(as % of merchandise exports) in Samoa?
Your response must be concise. 11.77. In the year 2006, what is the difference between the Exports(as % of merchandise exports) of High income: OECD and Exports(as % of merchandise exports) of Bosnia and Herzegovina?
Your response must be concise. 1.75. In the year 2006, what is the difference between the Exports(as % of merchandise exports) of High income: OECD and Exports(as % of merchandise exports) of Guatemala?
Your response must be concise. -43.12. In the year 2006, what is the difference between the Exports(as % of merchandise exports) in High income: OECD and Exports(as % of merchandise exports) in Samoa?
Your response must be concise. -15.43. In the year 2006, what is the difference between the Exports(as % of merchandise exports) in Bosnia and Herzegovina and Exports(as % of merchandise exports) in Guatemala?
Give a very brief answer. -44.88. In the year 2006, what is the difference between the Exports(as % of merchandise exports) of Bosnia and Herzegovina and Exports(as % of merchandise exports) of Samoa?
Offer a terse response. -17.18. In the year 2006, what is the difference between the Exports(as % of merchandise exports) in Guatemala and Exports(as % of merchandise exports) in Samoa?
Give a very brief answer. 27.7. In the year 2007, what is the difference between the Exports(as % of merchandise exports) of High income: OECD and Exports(as % of merchandise exports) of Bosnia and Herzegovina?
Your answer should be very brief. 1.57. In the year 2007, what is the difference between the Exports(as % of merchandise exports) of High income: OECD and Exports(as % of merchandise exports) of Guatemala?
Provide a short and direct response. -30.37. In the year 2007, what is the difference between the Exports(as % of merchandise exports) of High income: OECD and Exports(as % of merchandise exports) of Samoa?
Your answer should be very brief. -8.24. In the year 2007, what is the difference between the Exports(as % of merchandise exports) in Bosnia and Herzegovina and Exports(as % of merchandise exports) in Guatemala?
Keep it short and to the point. -31.94. In the year 2007, what is the difference between the Exports(as % of merchandise exports) in Bosnia and Herzegovina and Exports(as % of merchandise exports) in Samoa?
Your answer should be compact. -9.8. In the year 2007, what is the difference between the Exports(as % of merchandise exports) in Guatemala and Exports(as % of merchandise exports) in Samoa?
Give a very brief answer. 22.14. In the year 2008, what is the difference between the Exports(as % of merchandise exports) in High income: OECD and Exports(as % of merchandise exports) in Bosnia and Herzegovina?
Your response must be concise. 1.46. In the year 2008, what is the difference between the Exports(as % of merchandise exports) of High income: OECD and Exports(as % of merchandise exports) of Guatemala?
Keep it short and to the point. -30.24. In the year 2008, what is the difference between the Exports(as % of merchandise exports) of High income: OECD and Exports(as % of merchandise exports) of Samoa?
Your response must be concise. -6.9. In the year 2008, what is the difference between the Exports(as % of merchandise exports) of Bosnia and Herzegovina and Exports(as % of merchandise exports) of Guatemala?
Provide a short and direct response. -31.7. In the year 2008, what is the difference between the Exports(as % of merchandise exports) of Bosnia and Herzegovina and Exports(as % of merchandise exports) of Samoa?
Provide a short and direct response. -8.36. In the year 2008, what is the difference between the Exports(as % of merchandise exports) of Guatemala and Exports(as % of merchandise exports) of Samoa?
Keep it short and to the point. 23.34. In the year 2009, what is the difference between the Exports(as % of merchandise exports) in High income: OECD and Exports(as % of merchandise exports) in Bosnia and Herzegovina?
Provide a short and direct response. 0.73. In the year 2009, what is the difference between the Exports(as % of merchandise exports) in High income: OECD and Exports(as % of merchandise exports) in Guatemala?
Provide a succinct answer. -35.88. In the year 2009, what is the difference between the Exports(as % of merchandise exports) of High income: OECD and Exports(as % of merchandise exports) of Samoa?
Offer a terse response. -12.97. In the year 2009, what is the difference between the Exports(as % of merchandise exports) of Bosnia and Herzegovina and Exports(as % of merchandise exports) of Guatemala?
Give a very brief answer. -36.61. In the year 2009, what is the difference between the Exports(as % of merchandise exports) in Bosnia and Herzegovina and Exports(as % of merchandise exports) in Samoa?
Provide a succinct answer. -13.7. In the year 2009, what is the difference between the Exports(as % of merchandise exports) of Guatemala and Exports(as % of merchandise exports) of Samoa?
Provide a succinct answer. 22.91. In the year 2010, what is the difference between the Exports(as % of merchandise exports) in High income: OECD and Exports(as % of merchandise exports) in Bosnia and Herzegovina?
Offer a very short reply. 0.63. In the year 2010, what is the difference between the Exports(as % of merchandise exports) of High income: OECD and Exports(as % of merchandise exports) of Guatemala?
Your answer should be very brief. -34.12. In the year 2010, what is the difference between the Exports(as % of merchandise exports) in High income: OECD and Exports(as % of merchandise exports) in Samoa?
Your response must be concise. -13.09. In the year 2010, what is the difference between the Exports(as % of merchandise exports) of Bosnia and Herzegovina and Exports(as % of merchandise exports) of Guatemala?
Offer a very short reply. -34.75. In the year 2010, what is the difference between the Exports(as % of merchandise exports) of Bosnia and Herzegovina and Exports(as % of merchandise exports) of Samoa?
Ensure brevity in your answer.  -13.72. In the year 2010, what is the difference between the Exports(as % of merchandise exports) in Guatemala and Exports(as % of merchandise exports) in Samoa?
Make the answer very short. 21.03. In the year 2011, what is the difference between the Exports(as % of merchandise exports) in High income: OECD and Exports(as % of merchandise exports) in Bosnia and Herzegovina?
Offer a terse response. 1.34. In the year 2011, what is the difference between the Exports(as % of merchandise exports) of High income: OECD and Exports(as % of merchandise exports) of Guatemala?
Your answer should be very brief. -32.48. In the year 2011, what is the difference between the Exports(as % of merchandise exports) of High income: OECD and Exports(as % of merchandise exports) of Samoa?
Offer a terse response. -23.42. In the year 2011, what is the difference between the Exports(as % of merchandise exports) in Bosnia and Herzegovina and Exports(as % of merchandise exports) in Guatemala?
Your answer should be compact. -33.82. In the year 2011, what is the difference between the Exports(as % of merchandise exports) in Bosnia and Herzegovina and Exports(as % of merchandise exports) in Samoa?
Your response must be concise. -24.76. In the year 2011, what is the difference between the Exports(as % of merchandise exports) of Guatemala and Exports(as % of merchandise exports) of Samoa?
Offer a very short reply. 9.06. What is the ratio of the Exports(as % of merchandise exports) of High income: OECD in 2004 to that in 2005?
Make the answer very short. 1.03. What is the ratio of the Exports(as % of merchandise exports) of Bosnia and Herzegovina in 2004 to that in 2005?
Offer a very short reply. 0.76. What is the ratio of the Exports(as % of merchandise exports) in Guatemala in 2004 to that in 2005?
Give a very brief answer. 1.34. What is the ratio of the Exports(as % of merchandise exports) in Samoa in 2004 to that in 2005?
Provide a short and direct response. 1.02. What is the ratio of the Exports(as % of merchandise exports) in High income: OECD in 2004 to that in 2006?
Provide a succinct answer. 1.07. What is the ratio of the Exports(as % of merchandise exports) in Bosnia and Herzegovina in 2004 to that in 2006?
Keep it short and to the point. 0.89. What is the ratio of the Exports(as % of merchandise exports) in Guatemala in 2004 to that in 2006?
Offer a terse response. 0.91. What is the ratio of the Exports(as % of merchandise exports) of Samoa in 2004 to that in 2006?
Make the answer very short. 1.02. What is the ratio of the Exports(as % of merchandise exports) of High income: OECD in 2004 to that in 2007?
Make the answer very short. 1.02. What is the ratio of the Exports(as % of merchandise exports) of Bosnia and Herzegovina in 2004 to that in 2007?
Keep it short and to the point. 0.81. What is the ratio of the Exports(as % of merchandise exports) in Guatemala in 2004 to that in 2007?
Give a very brief answer. 1.21. What is the ratio of the Exports(as % of merchandise exports) of Samoa in 2004 to that in 2007?
Offer a terse response. 1.48. What is the ratio of the Exports(as % of merchandise exports) of High income: OECD in 2004 to that in 2008?
Give a very brief answer. 0.96. What is the ratio of the Exports(as % of merchandise exports) in Bosnia and Herzegovina in 2004 to that in 2008?
Make the answer very short. 0.73. What is the ratio of the Exports(as % of merchandise exports) of Guatemala in 2004 to that in 2008?
Your response must be concise. 1.2. What is the ratio of the Exports(as % of merchandise exports) in Samoa in 2004 to that in 2008?
Your answer should be compact. 1.57. What is the ratio of the Exports(as % of merchandise exports) in High income: OECD in 2004 to that in 2009?
Give a very brief answer. 0.85. What is the ratio of the Exports(as % of merchandise exports) of Bosnia and Herzegovina in 2004 to that in 2009?
Keep it short and to the point. 0.57. What is the ratio of the Exports(as % of merchandise exports) in Guatemala in 2004 to that in 2009?
Ensure brevity in your answer.  1.02. What is the ratio of the Exports(as % of merchandise exports) of Samoa in 2004 to that in 2009?
Offer a terse response. 1.05. What is the ratio of the Exports(as % of merchandise exports) in High income: OECD in 2004 to that in 2010?
Ensure brevity in your answer.  0.9. What is the ratio of the Exports(as % of merchandise exports) in Bosnia and Herzegovina in 2004 to that in 2010?
Give a very brief answer. 0.6. What is the ratio of the Exports(as % of merchandise exports) in Guatemala in 2004 to that in 2010?
Give a very brief answer. 1.07. What is the ratio of the Exports(as % of merchandise exports) of Samoa in 2004 to that in 2010?
Ensure brevity in your answer.  1.07. What is the ratio of the Exports(as % of merchandise exports) of High income: OECD in 2004 to that in 2011?
Your answer should be very brief. 0.87. What is the ratio of the Exports(as % of merchandise exports) of Bosnia and Herzegovina in 2004 to that in 2011?
Offer a very short reply. 0.64. What is the ratio of the Exports(as % of merchandise exports) of Guatemala in 2004 to that in 2011?
Your answer should be very brief. 1.11. What is the ratio of the Exports(as % of merchandise exports) of Samoa in 2004 to that in 2011?
Keep it short and to the point. 0.71. What is the ratio of the Exports(as % of merchandise exports) in High income: OECD in 2005 to that in 2006?
Provide a succinct answer. 1.03. What is the ratio of the Exports(as % of merchandise exports) of Bosnia and Herzegovina in 2005 to that in 2006?
Provide a short and direct response. 1.17. What is the ratio of the Exports(as % of merchandise exports) of Guatemala in 2005 to that in 2006?
Offer a very short reply. 0.68. What is the ratio of the Exports(as % of merchandise exports) in Bosnia and Herzegovina in 2005 to that in 2007?
Give a very brief answer. 1.07. What is the ratio of the Exports(as % of merchandise exports) of Guatemala in 2005 to that in 2007?
Give a very brief answer. 0.91. What is the ratio of the Exports(as % of merchandise exports) in Samoa in 2005 to that in 2007?
Give a very brief answer. 1.45. What is the ratio of the Exports(as % of merchandise exports) in High income: OECD in 2005 to that in 2008?
Keep it short and to the point. 0.93. What is the ratio of the Exports(as % of merchandise exports) in Bosnia and Herzegovina in 2005 to that in 2008?
Provide a short and direct response. 0.97. What is the ratio of the Exports(as % of merchandise exports) in Guatemala in 2005 to that in 2008?
Offer a terse response. 0.9. What is the ratio of the Exports(as % of merchandise exports) of Samoa in 2005 to that in 2008?
Your answer should be compact. 1.54. What is the ratio of the Exports(as % of merchandise exports) of High income: OECD in 2005 to that in 2009?
Provide a succinct answer. 0.82. What is the ratio of the Exports(as % of merchandise exports) of Bosnia and Herzegovina in 2005 to that in 2009?
Provide a succinct answer. 0.75. What is the ratio of the Exports(as % of merchandise exports) of Guatemala in 2005 to that in 2009?
Make the answer very short. 0.76. What is the ratio of the Exports(as % of merchandise exports) in Samoa in 2005 to that in 2009?
Your answer should be compact. 1.03. What is the ratio of the Exports(as % of merchandise exports) of High income: OECD in 2005 to that in 2010?
Ensure brevity in your answer.  0.87. What is the ratio of the Exports(as % of merchandise exports) in Bosnia and Herzegovina in 2005 to that in 2010?
Offer a very short reply. 0.79. What is the ratio of the Exports(as % of merchandise exports) of Guatemala in 2005 to that in 2010?
Offer a very short reply. 0.8. What is the ratio of the Exports(as % of merchandise exports) in Samoa in 2005 to that in 2010?
Offer a very short reply. 1.05. What is the ratio of the Exports(as % of merchandise exports) of High income: OECD in 2005 to that in 2011?
Offer a terse response. 0.84. What is the ratio of the Exports(as % of merchandise exports) in Bosnia and Herzegovina in 2005 to that in 2011?
Ensure brevity in your answer.  0.85. What is the ratio of the Exports(as % of merchandise exports) in Guatemala in 2005 to that in 2011?
Your answer should be very brief. 0.83. What is the ratio of the Exports(as % of merchandise exports) of Samoa in 2005 to that in 2011?
Give a very brief answer. 0.7. What is the ratio of the Exports(as % of merchandise exports) in High income: OECD in 2006 to that in 2007?
Make the answer very short. 0.96. What is the ratio of the Exports(as % of merchandise exports) of Bosnia and Herzegovina in 2006 to that in 2007?
Keep it short and to the point. 0.92. What is the ratio of the Exports(as % of merchandise exports) in Guatemala in 2006 to that in 2007?
Offer a terse response. 1.33. What is the ratio of the Exports(as % of merchandise exports) of Samoa in 2006 to that in 2007?
Provide a short and direct response. 1.46. What is the ratio of the Exports(as % of merchandise exports) of High income: OECD in 2006 to that in 2008?
Your response must be concise. 0.9. What is the ratio of the Exports(as % of merchandise exports) in Bosnia and Herzegovina in 2006 to that in 2008?
Your answer should be very brief. 0.83. What is the ratio of the Exports(as % of merchandise exports) in Guatemala in 2006 to that in 2008?
Offer a very short reply. 1.32. What is the ratio of the Exports(as % of merchandise exports) of Samoa in 2006 to that in 2008?
Make the answer very short. 1.54. What is the ratio of the Exports(as % of merchandise exports) of High income: OECD in 2006 to that in 2009?
Offer a very short reply. 0.79. What is the ratio of the Exports(as % of merchandise exports) in Bosnia and Herzegovina in 2006 to that in 2009?
Your answer should be very brief. 0.64. What is the ratio of the Exports(as % of merchandise exports) of Guatemala in 2006 to that in 2009?
Offer a very short reply. 1.12. What is the ratio of the Exports(as % of merchandise exports) of Samoa in 2006 to that in 2009?
Keep it short and to the point. 1.03. What is the ratio of the Exports(as % of merchandise exports) of High income: OECD in 2006 to that in 2010?
Your answer should be very brief. 0.84. What is the ratio of the Exports(as % of merchandise exports) in Bosnia and Herzegovina in 2006 to that in 2010?
Offer a terse response. 0.67. What is the ratio of the Exports(as % of merchandise exports) of Guatemala in 2006 to that in 2010?
Give a very brief answer. 1.18. What is the ratio of the Exports(as % of merchandise exports) of Samoa in 2006 to that in 2010?
Your response must be concise. 1.05. What is the ratio of the Exports(as % of merchandise exports) of High income: OECD in 2006 to that in 2011?
Provide a short and direct response. 0.82. What is the ratio of the Exports(as % of merchandise exports) in Bosnia and Herzegovina in 2006 to that in 2011?
Keep it short and to the point. 0.72. What is the ratio of the Exports(as % of merchandise exports) in Guatemala in 2006 to that in 2011?
Ensure brevity in your answer.  1.23. What is the ratio of the Exports(as % of merchandise exports) in Samoa in 2006 to that in 2011?
Give a very brief answer. 0.7. What is the ratio of the Exports(as % of merchandise exports) in High income: OECD in 2007 to that in 2008?
Keep it short and to the point. 0.94. What is the ratio of the Exports(as % of merchandise exports) in Bosnia and Herzegovina in 2007 to that in 2008?
Offer a terse response. 0.9. What is the ratio of the Exports(as % of merchandise exports) in Guatemala in 2007 to that in 2008?
Make the answer very short. 0.99. What is the ratio of the Exports(as % of merchandise exports) in Samoa in 2007 to that in 2008?
Ensure brevity in your answer.  1.06. What is the ratio of the Exports(as % of merchandise exports) in High income: OECD in 2007 to that in 2009?
Provide a short and direct response. 0.83. What is the ratio of the Exports(as % of merchandise exports) of Bosnia and Herzegovina in 2007 to that in 2009?
Ensure brevity in your answer.  0.7. What is the ratio of the Exports(as % of merchandise exports) of Guatemala in 2007 to that in 2009?
Your answer should be very brief. 0.84. What is the ratio of the Exports(as % of merchandise exports) in Samoa in 2007 to that in 2009?
Keep it short and to the point. 0.71. What is the ratio of the Exports(as % of merchandise exports) of High income: OECD in 2007 to that in 2010?
Your response must be concise. 0.88. What is the ratio of the Exports(as % of merchandise exports) of Bosnia and Herzegovina in 2007 to that in 2010?
Offer a terse response. 0.74. What is the ratio of the Exports(as % of merchandise exports) in Guatemala in 2007 to that in 2010?
Provide a short and direct response. 0.89. What is the ratio of the Exports(as % of merchandise exports) in Samoa in 2007 to that in 2010?
Provide a short and direct response. 0.72. What is the ratio of the Exports(as % of merchandise exports) in High income: OECD in 2007 to that in 2011?
Your response must be concise. 0.85. What is the ratio of the Exports(as % of merchandise exports) of Bosnia and Herzegovina in 2007 to that in 2011?
Make the answer very short. 0.79. What is the ratio of the Exports(as % of merchandise exports) in Guatemala in 2007 to that in 2011?
Your answer should be compact. 0.92. What is the ratio of the Exports(as % of merchandise exports) in Samoa in 2007 to that in 2011?
Make the answer very short. 0.48. What is the ratio of the Exports(as % of merchandise exports) in High income: OECD in 2008 to that in 2009?
Keep it short and to the point. 0.88. What is the ratio of the Exports(as % of merchandise exports) in Bosnia and Herzegovina in 2008 to that in 2009?
Your answer should be very brief. 0.78. What is the ratio of the Exports(as % of merchandise exports) of Guatemala in 2008 to that in 2009?
Provide a succinct answer. 0.85. What is the ratio of the Exports(as % of merchandise exports) of Samoa in 2008 to that in 2009?
Provide a short and direct response. 0.67. What is the ratio of the Exports(as % of merchandise exports) in High income: OECD in 2008 to that in 2010?
Give a very brief answer. 0.94. What is the ratio of the Exports(as % of merchandise exports) in Bosnia and Herzegovina in 2008 to that in 2010?
Your answer should be very brief. 0.82. What is the ratio of the Exports(as % of merchandise exports) in Guatemala in 2008 to that in 2010?
Keep it short and to the point. 0.9. What is the ratio of the Exports(as % of merchandise exports) of Samoa in 2008 to that in 2010?
Your answer should be very brief. 0.68. What is the ratio of the Exports(as % of merchandise exports) of High income: OECD in 2008 to that in 2011?
Offer a very short reply. 0.91. What is the ratio of the Exports(as % of merchandise exports) of Bosnia and Herzegovina in 2008 to that in 2011?
Your answer should be compact. 0.88. What is the ratio of the Exports(as % of merchandise exports) of Guatemala in 2008 to that in 2011?
Your response must be concise. 0.93. What is the ratio of the Exports(as % of merchandise exports) in Samoa in 2008 to that in 2011?
Your answer should be compact. 0.45. What is the ratio of the Exports(as % of merchandise exports) in High income: OECD in 2009 to that in 2010?
Offer a terse response. 1.06. What is the ratio of the Exports(as % of merchandise exports) of Bosnia and Herzegovina in 2009 to that in 2010?
Offer a terse response. 1.05. What is the ratio of the Exports(as % of merchandise exports) in Guatemala in 2009 to that in 2010?
Keep it short and to the point. 1.05. What is the ratio of the Exports(as % of merchandise exports) in Samoa in 2009 to that in 2010?
Offer a terse response. 1.02. What is the ratio of the Exports(as % of merchandise exports) in High income: OECD in 2009 to that in 2011?
Ensure brevity in your answer.  1.03. What is the ratio of the Exports(as % of merchandise exports) of Bosnia and Herzegovina in 2009 to that in 2011?
Your answer should be compact. 1.13. What is the ratio of the Exports(as % of merchandise exports) in Guatemala in 2009 to that in 2011?
Ensure brevity in your answer.  1.09. What is the ratio of the Exports(as % of merchandise exports) in Samoa in 2009 to that in 2011?
Provide a succinct answer. 0.68. What is the ratio of the Exports(as % of merchandise exports) of Bosnia and Herzegovina in 2010 to that in 2011?
Offer a very short reply. 1.07. What is the ratio of the Exports(as % of merchandise exports) in Guatemala in 2010 to that in 2011?
Your answer should be compact. 1.04. What is the ratio of the Exports(as % of merchandise exports) in Samoa in 2010 to that in 2011?
Your response must be concise. 0.67. What is the difference between the highest and the second highest Exports(as % of merchandise exports) of High income: OECD?
Your answer should be compact. 0.27. What is the difference between the highest and the second highest Exports(as % of merchandise exports) in Bosnia and Herzegovina?
Ensure brevity in your answer.  0.37. What is the difference between the highest and the second highest Exports(as % of merchandise exports) of Guatemala?
Keep it short and to the point. 4.61. What is the difference between the highest and the second highest Exports(as % of merchandise exports) in Samoa?
Keep it short and to the point. 9.08. What is the difference between the highest and the lowest Exports(as % of merchandise exports) in High income: OECD?
Your answer should be compact. 1.74. What is the difference between the highest and the lowest Exports(as % of merchandise exports) in Bosnia and Herzegovina?
Ensure brevity in your answer.  3.31. What is the difference between the highest and the lowest Exports(as % of merchandise exports) in Guatemala?
Make the answer very short. 15.99. What is the difference between the highest and the lowest Exports(as % of merchandise exports) of Samoa?
Give a very brief answer. 17.24. 